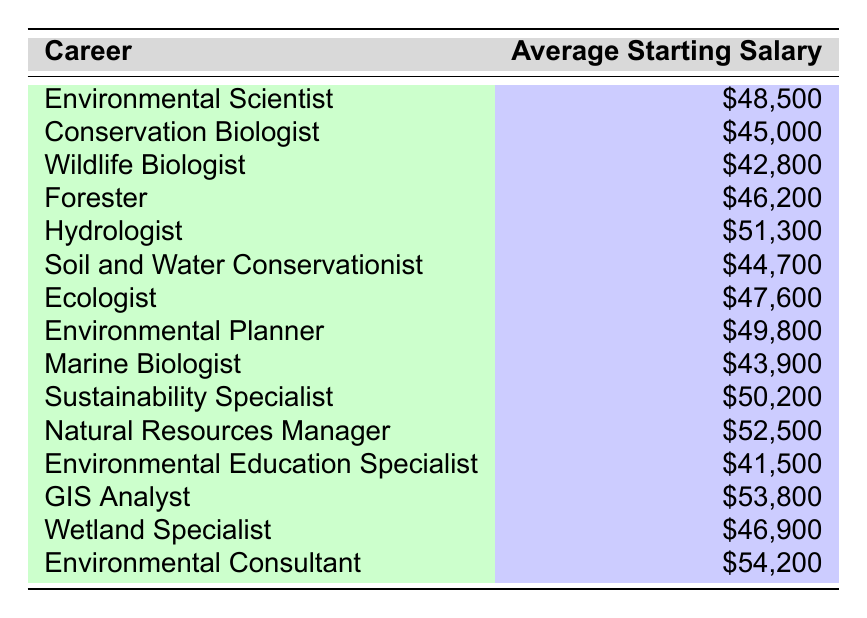What is the average starting salary for a Hydrologist? The salary listed for a Hydrologist in the table is $51,300.
Answer: $51,300 Which career has the lowest average starting salary? The lowest salary in the table is for an Environmental Education Specialist, which is $41,500.
Answer: $41,500 What is the difference in starting salary between a Wildlife Biologist and a Conservation Biologist? The starting salary for a Wildlife Biologist is $42,800 and for a Conservation Biologist is $45,000. The difference is $45,000 - $42,800 = $2,200.
Answer: $2,200 Is the average starting salary for a Soil and Water Conservationist higher or lower than $45,000? The average starting salary for a Soil and Water Conservationist is $44,700, which is lower than $45,000.
Answer: Lower What is the average starting salary of the top three highest-paying careers in this table? The top three highest salaries are $54,200 (Environmental Consultant), $53,800 (GIS Analyst), and $52,500 (Natural Resources Manager). Adding these gives $54,200 + $53,800 + $52,500 = $160,500. Dividing by 3 gives an average of $160,500 / 3 = $53,500.
Answer: $53,500 How many careers have an average starting salary above $50,000? The careers above $50,000 are Hydrologist ($51,300), Sustainability Specialist ($50,200), Natural Resources Manager ($52,500), GIS Analyst ($53,800), and Environmental Consultant ($54,200). This totals 5 careers above $50,000.
Answer: 5 If you were to sum the average starting salaries of the Forester and the Ecologist, what would that total be? The average salary for a Forester is $46,200 and for an Ecologist is $47,600. The sum is $46,200 + $47,600 = $93,800.
Answer: $93,800 What percentage of the careers listed have an average starting salary below $45,000? There are 14 careers total and 4 of them (Wildlife Biologist, Soil and Water Conservationist, Marine Biologist, Environmental Education Specialist) have salaries below $45,000. The percentage is (4/14) * 100 = 28.57%, which is approximately 29%.
Answer: 29% Which career has a starting salary closest to $50,000 without exceeding it? The closest salary to $50,000 without exceeding it is for an Environmental Planner at $49,800.
Answer: Environmental Planner What is the total of the average starting salaries for the careers listed? By summing all the salaries: $48,500 + $45,000 + $42,800 + $46,200 + $51,300 + $44,700 + $47,600 + $49,800 + $43,900 + $50,200 + $52,500 + $41,500 + $53,800 + $46,900 + $54,200 = $759,100.
Answer: $759,100 